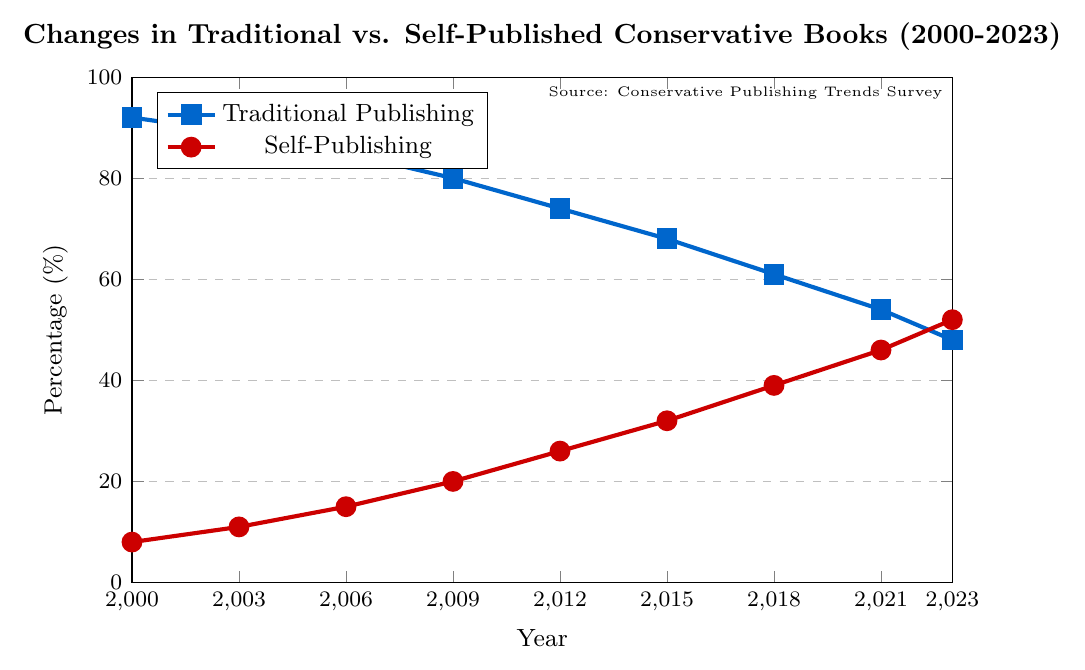What year did self-publishing surpass traditional publishing? The figure shows self-publishing surpass traditional publishing when the percentage of self-published books becomes greater than the percentage of traditionally published books. This happens in 2023, where self-publishing is at 52% and traditional publishing is at 48%
Answer: 2023 By how much did the percentage of traditionally published books decrease from 2000 to 2023? To find the decrease, subtract the percentage of traditional publishing in 2023 from that in 2000. The percentage in 2000 is 92% and in 2023 is 48%, so the decrease is 92% - 48% = 44%
Answer: 44% What is the overall trend in the percentage of self-published conservative books from 2000 to 2023? Observing the figure, the percentage of self-published books increases steadily over the years from 8% in 2000 to 52% in 2023. This shows a clear upward trend
Answer: Upward trend In which year was the percentage of traditionally published books closest to 60%? The figure indicates that the percentage of traditionally published books is closest to 60% in 2018 when it is at 61%
Answer: 2018 What is the average percentage of self-published books from 2000 to 2023? To find the average, sum the percentages of self-published books across all years and divide by the number of data points. The percentages are 8%, 11%, 15%, 20%, 26%, 32%, 39%, 46%, and 52%. Summing these gives 249%, and dividing by 9 gives approximately 27.67%
Answer: 27.67% Which publishing category has a higher percentage in 2009? The figure shows that in 2009, traditional publishing has a percentage of 80% and self-publishing has 20%. Since 80% is greater than 20%, traditional publishing has a higher percentage
Answer: Traditional publishing How many percentage points did self-publishing increase between 2012 and 2023? Subtract the percentage of self-publishing in 2012 (26%) from that in 2023 (52%). The increase is 52% - 26% = 26%
Answer: 26% Describe the color and shape of the markers used for traditional publishing in the plot. The markers for traditional publishing in the figure are squares and colored blue
Answer: Blue squares Which year has the largest difference between the percentages of traditional and self-publishing? The figure shows that the largest difference appears in 2000 when traditional publishing is 92% and self-publishing is 8%. The difference is 92% - 8% = 84%
Answer: 2000 By how many percentage points did traditional publishing decrease from 2015 to 2018? The traditional publishing percentage in 2015 is 68% and in 2018 it is 61%. The decrease is 68% - 61% = 7%
Answer: 7% 